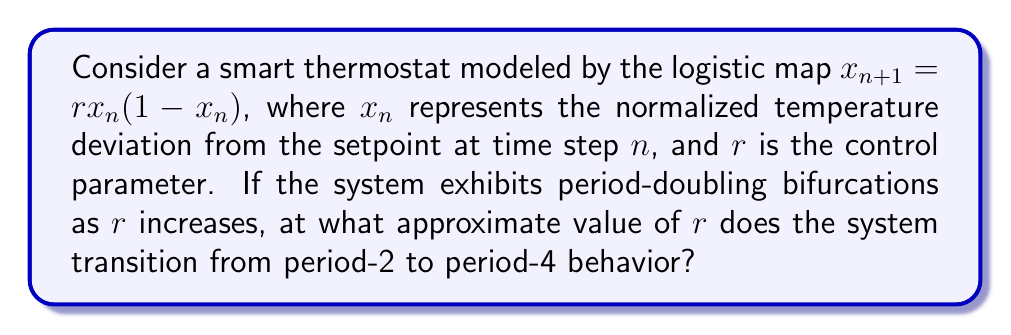Help me with this question. To solve this problem, we need to understand the behavior of the logistic map and its bifurcation diagram:

1. The logistic map $x_{n+1} = rx_n(1-x_n)$ is a classic example in chaos theory.

2. As $r$ increases, the system undergoes period-doubling bifurcations:
   - For $0 < r < 3$, the system converges to a fixed point.
   - At $r = 3$, the first period-doubling occurs (period-1 to period-2).
   - As $r$ increases further, more period-doubling bifurcations occur.

3. The Feigenbaum constant $\delta \approx 4.669201...$ describes the asymptotic ratio of successive bifurcation intervals.

4. Let $r_1 = 3$ be the first bifurcation point (period-1 to period-2).

5. The second bifurcation point $r_2$ (period-2 to period-4) can be approximated using the Feigenbaum constant:

   $$r_2 \approx r_1 + \frac{r_2 - r_1}{\delta}$$

6. Solving for $r_2$:
   $$r_2 \approx r_1 + \frac{r_1 - r_0}{\delta}$$
   Where $r_0 = 1$ (the point where oscillations begin).

7. Substituting the values:
   $$r_2 \approx 3 + \frac{3 - 1}{4.669201} \approx 3.4494897$$

Therefore, the transition from period-2 to period-4 behavior occurs at approximately $r = 3.4494897$.
Answer: $r \approx 3.4494897$ 